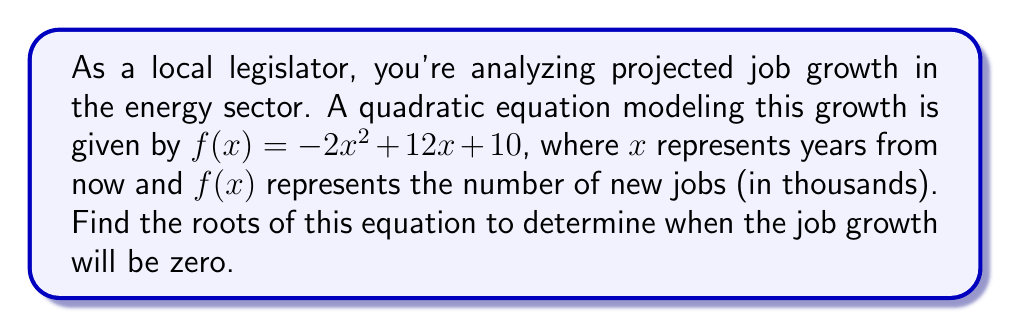Can you solve this math problem? To find the roots of the quadratic equation, we need to solve $f(x) = 0$. Let's approach this step-by-step:

1) We start with the equation:
   $-2x^2 + 12x + 10 = 0$

2) We can factor out the greatest common factor:
   $-2(x^2 - 6x - 5) = 0$

3) Divide both sides by -2:
   $x^2 - 6x - 5 = 0$

4) Now we can use the quadratic formula: $x = \frac{-b \pm \sqrt{b^2 - 4ac}}{2a}$
   Where $a = 1$, $b = -6$, and $c = -5$

5) Plugging these values into the quadratic formula:
   $$x = \frac{-(-6) \pm \sqrt{(-6)^2 - 4(1)(-5)}}{2(1)}$$

6) Simplify:
   $$x = \frac{6 \pm \sqrt{36 + 20}}{2} = \frac{6 \pm \sqrt{56}}{2} = \frac{6 \pm 2\sqrt{14}}{2}$$

7) Further simplify:
   $$x = 3 \pm \sqrt{14}$$

Therefore, the roots are:
$x_1 = 3 + \sqrt{14}$ and $x_2 = 3 - \sqrt{14}$

These roots represent the times (in years from now) when the job growth will be zero.
Answer: The roots of the equation are $x_1 = 3 + \sqrt{14}$ and $x_2 = 3 - \sqrt{14}$. 